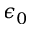<formula> <loc_0><loc_0><loc_500><loc_500>\epsilon _ { 0 }</formula> 